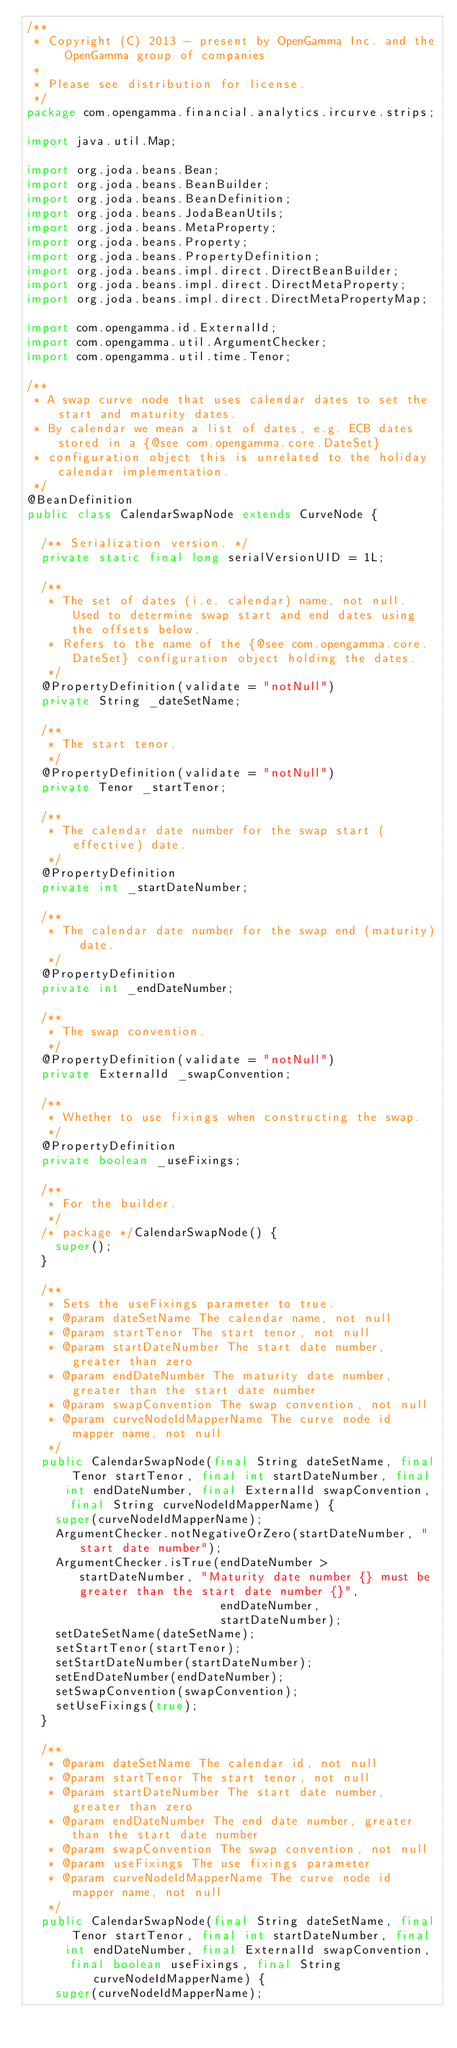Convert code to text. <code><loc_0><loc_0><loc_500><loc_500><_Java_>/**
 * Copyright (C) 2013 - present by OpenGamma Inc. and the OpenGamma group of companies
 *
 * Please see distribution for license.
 */
package com.opengamma.financial.analytics.ircurve.strips;

import java.util.Map;

import org.joda.beans.Bean;
import org.joda.beans.BeanBuilder;
import org.joda.beans.BeanDefinition;
import org.joda.beans.JodaBeanUtils;
import org.joda.beans.MetaProperty;
import org.joda.beans.Property;
import org.joda.beans.PropertyDefinition;
import org.joda.beans.impl.direct.DirectBeanBuilder;
import org.joda.beans.impl.direct.DirectMetaProperty;
import org.joda.beans.impl.direct.DirectMetaPropertyMap;

import com.opengamma.id.ExternalId;
import com.opengamma.util.ArgumentChecker;
import com.opengamma.util.time.Tenor;

/**
 * A swap curve node that uses calendar dates to set the start and maturity dates.
 * By calendar we mean a list of dates, e.g. ECB dates stored in a {@see com.opengamma.core.DateSet}
 * configuration object this is unrelated to the holiday calendar implementation.
 */
@BeanDefinition
public class CalendarSwapNode extends CurveNode {

  /** Serialization version. */
  private static final long serialVersionUID = 1L;

  /**
   * The set of dates (i.e. calendar) name, not null. Used to determine swap start and end dates using the offsets below.
   * Refers to the name of the {@see com.opengamma.core.DateSet} configuration object holding the dates.
   */
  @PropertyDefinition(validate = "notNull")
  private String _dateSetName;
  
  /**
   * The start tenor.
   */
  @PropertyDefinition(validate = "notNull")
  private Tenor _startTenor;

  /**
   * The calendar date number for the swap start (effective) date.
   */
  @PropertyDefinition
  private int _startDateNumber;

  /**
   * The calendar date number for the swap end (maturity) date.
   */
  @PropertyDefinition
  private int _endDateNumber;

  /**
   * The swap convention.
   */
  @PropertyDefinition(validate = "notNull")
  private ExternalId _swapConvention;

  /**
   * Whether to use fixings when constructing the swap.
   */
  @PropertyDefinition
  private boolean _useFixings;

  /**
   * For the builder.
   */
  /* package */CalendarSwapNode() {
    super();
  }

  /**
   * Sets the useFixings parameter to true.
   * @param dateSetName The calendar name, not null
   * @param startTenor The start tenor, not null
   * @param startDateNumber The start date number, greater than zero
   * @param endDateNumber The maturity date number, greater than the start date number
   * @param swapConvention The swap convention, not null
   * @param curveNodeIdMapperName The curve node id mapper name, not null
   */
  public CalendarSwapNode(final String dateSetName, final Tenor startTenor, final int startDateNumber, final int endDateNumber, final ExternalId swapConvention,
      final String curveNodeIdMapperName) {
    super(curveNodeIdMapperName);
    ArgumentChecker.notNegativeOrZero(startDateNumber, "start date number");
    ArgumentChecker.isTrue(endDateNumber > startDateNumber, "Maturity date number {} must be greater than the start date number {}",
                           endDateNumber,
                           startDateNumber);
    setDateSetName(dateSetName);
    setStartTenor(startTenor);
    setStartDateNumber(startDateNumber);
    setEndDateNumber(endDateNumber);
    setSwapConvention(swapConvention);
    setUseFixings(true);
  }

  /**
   * @param dateSetName The calendar id, not null
   * @param startTenor The start tenor, not null
   * @param startDateNumber The start date number, greater than zero
   * @param endDateNumber The end date number, greater than the start date number
   * @param swapConvention The swap convention, not null
   * @param useFixings The use fixings parameter
   * @param curveNodeIdMapperName The curve node id mapper name, not null
   */
  public CalendarSwapNode(final String dateSetName, final Tenor startTenor, final int startDateNumber, final int endDateNumber, final ExternalId swapConvention,
      final boolean useFixings, final String curveNodeIdMapperName) {
    super(curveNodeIdMapperName);</code> 